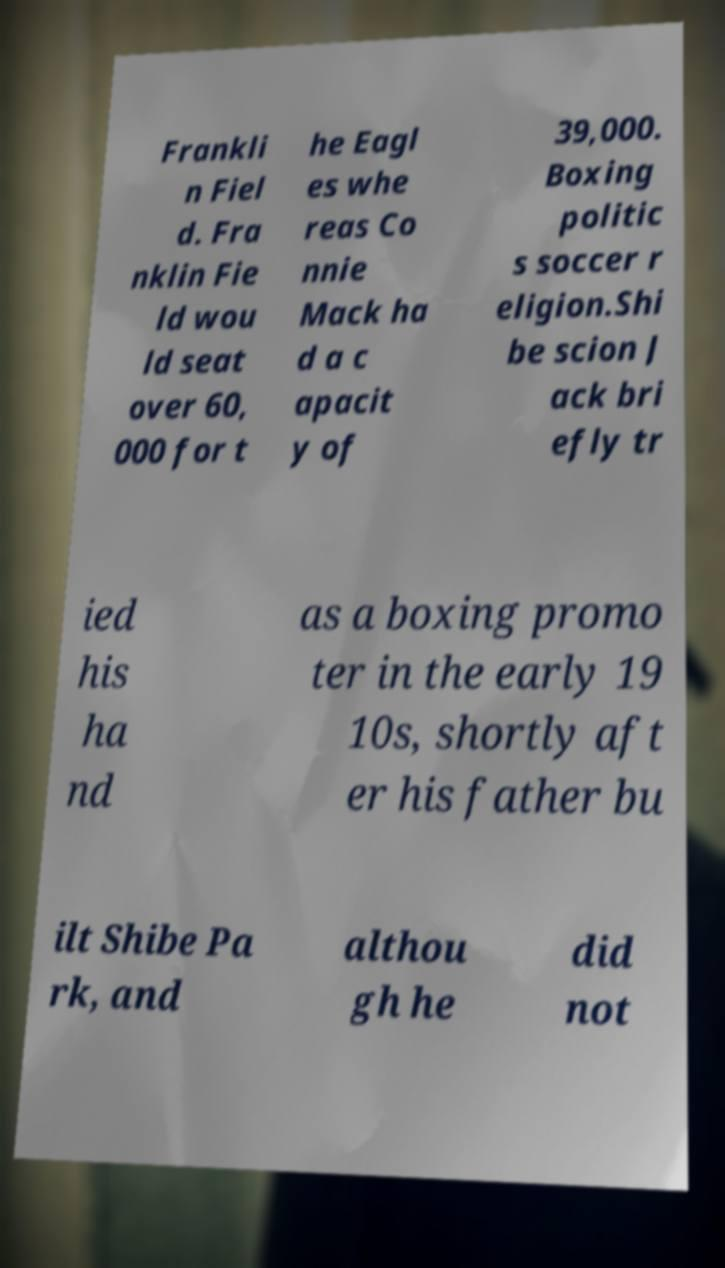There's text embedded in this image that I need extracted. Can you transcribe it verbatim? Frankli n Fiel d. Fra nklin Fie ld wou ld seat over 60, 000 for t he Eagl es whe reas Co nnie Mack ha d a c apacit y of 39,000. Boxing politic s soccer r eligion.Shi be scion J ack bri efly tr ied his ha nd as a boxing promo ter in the early 19 10s, shortly aft er his father bu ilt Shibe Pa rk, and althou gh he did not 